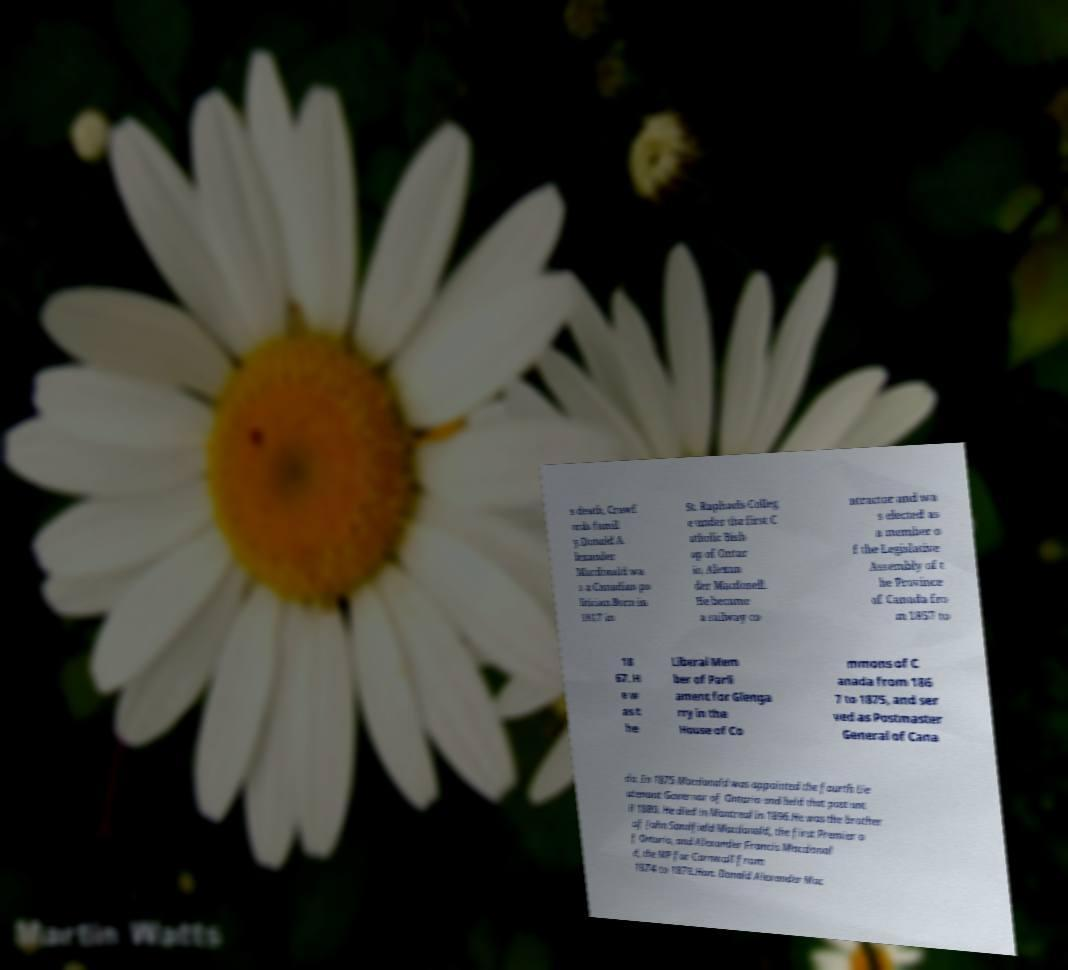Can you accurately transcribe the text from the provided image for me? s death, Crawf ords famil y.Donald A lexander Macdonald wa s a Canadian po litician.Born in 1817 in St. Raphaels Colleg e under the first C atholic Bish op of Ontar io, Alexan der Macdonell. He became a railway co ntractor and wa s elected as a member o f the Legislative Assembly of t he Province of Canada fro m 1857 to 18 67. H e w as t he Liberal Mem ber of Parli ament for Glenga rry in the House of Co mmons of C anada from 186 7 to 1875, and ser ved as Postmaster General of Cana da. In 1875 Macdonald was appointed the fourth Lie utenant Governor of Ontario and held that post unt il 1880. He died in Montreal in 1896.He was the brother of John Sandfield Macdonald, the first Premier o f Ontario, and Alexander Francis Macdonal d, the MP for Cornwall from 1874 to 1878.Hon. Donald Alexander Mac 